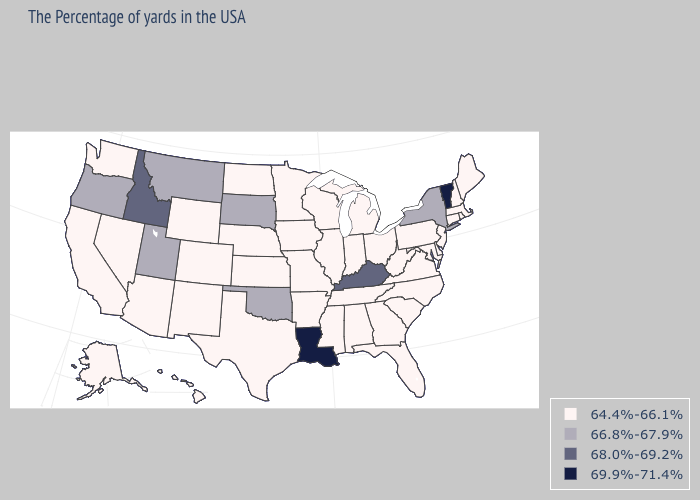Does the map have missing data?
Answer briefly. No. What is the value of Illinois?
Concise answer only. 64.4%-66.1%. Which states have the highest value in the USA?
Write a very short answer. Vermont, Louisiana. Is the legend a continuous bar?
Answer briefly. No. Name the states that have a value in the range 64.4%-66.1%?
Answer briefly. Maine, Massachusetts, Rhode Island, New Hampshire, Connecticut, New Jersey, Delaware, Maryland, Pennsylvania, Virginia, North Carolina, South Carolina, West Virginia, Ohio, Florida, Georgia, Michigan, Indiana, Alabama, Tennessee, Wisconsin, Illinois, Mississippi, Missouri, Arkansas, Minnesota, Iowa, Kansas, Nebraska, Texas, North Dakota, Wyoming, Colorado, New Mexico, Arizona, Nevada, California, Washington, Alaska, Hawaii. What is the value of New Hampshire?
Quick response, please. 64.4%-66.1%. Does Montana have a higher value than South Dakota?
Keep it brief. No. Does New York have the same value as Vermont?
Give a very brief answer. No. Does the map have missing data?
Be succinct. No. What is the value of California?
Be succinct. 64.4%-66.1%. Is the legend a continuous bar?
Give a very brief answer. No. Name the states that have a value in the range 64.4%-66.1%?
Be succinct. Maine, Massachusetts, Rhode Island, New Hampshire, Connecticut, New Jersey, Delaware, Maryland, Pennsylvania, Virginia, North Carolina, South Carolina, West Virginia, Ohio, Florida, Georgia, Michigan, Indiana, Alabama, Tennessee, Wisconsin, Illinois, Mississippi, Missouri, Arkansas, Minnesota, Iowa, Kansas, Nebraska, Texas, North Dakota, Wyoming, Colorado, New Mexico, Arizona, Nevada, California, Washington, Alaska, Hawaii. Does Louisiana have the highest value in the USA?
Give a very brief answer. Yes. Name the states that have a value in the range 69.9%-71.4%?
Concise answer only. Vermont, Louisiana. What is the highest value in the USA?
Concise answer only. 69.9%-71.4%. 